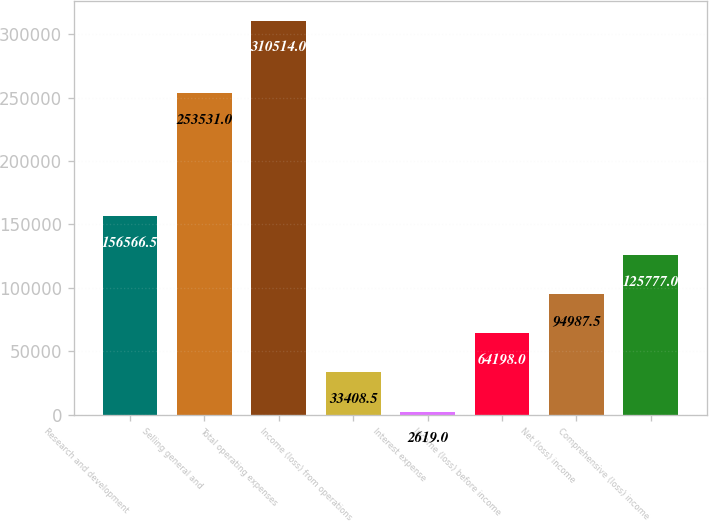<chart> <loc_0><loc_0><loc_500><loc_500><bar_chart><fcel>Research and development<fcel>Selling general and<fcel>Total operating expenses<fcel>Income (loss) from operations<fcel>Interest expense<fcel>Income (loss) before income<fcel>Net (loss) income<fcel>Comprehensive (loss) income<nl><fcel>156566<fcel>253531<fcel>310514<fcel>33408.5<fcel>2619<fcel>64198<fcel>94987.5<fcel>125777<nl></chart> 